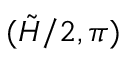<formula> <loc_0><loc_0><loc_500><loc_500>( \tilde { H } / 2 , \pi )</formula> 